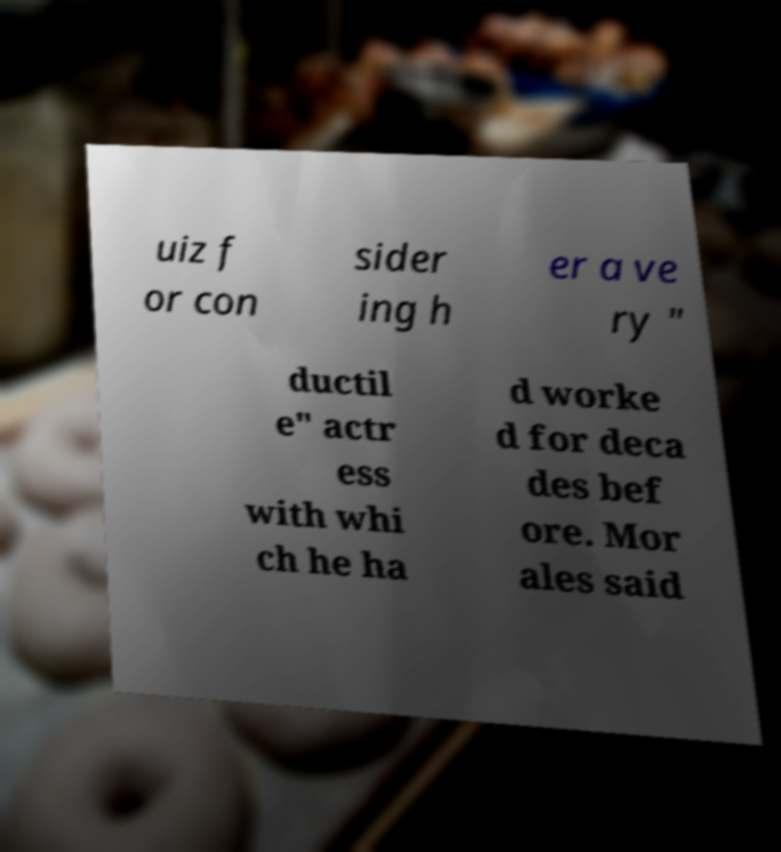Please read and relay the text visible in this image. What does it say? uiz f or con sider ing h er a ve ry " ductil e" actr ess with whi ch he ha d worke d for deca des bef ore. Mor ales said 